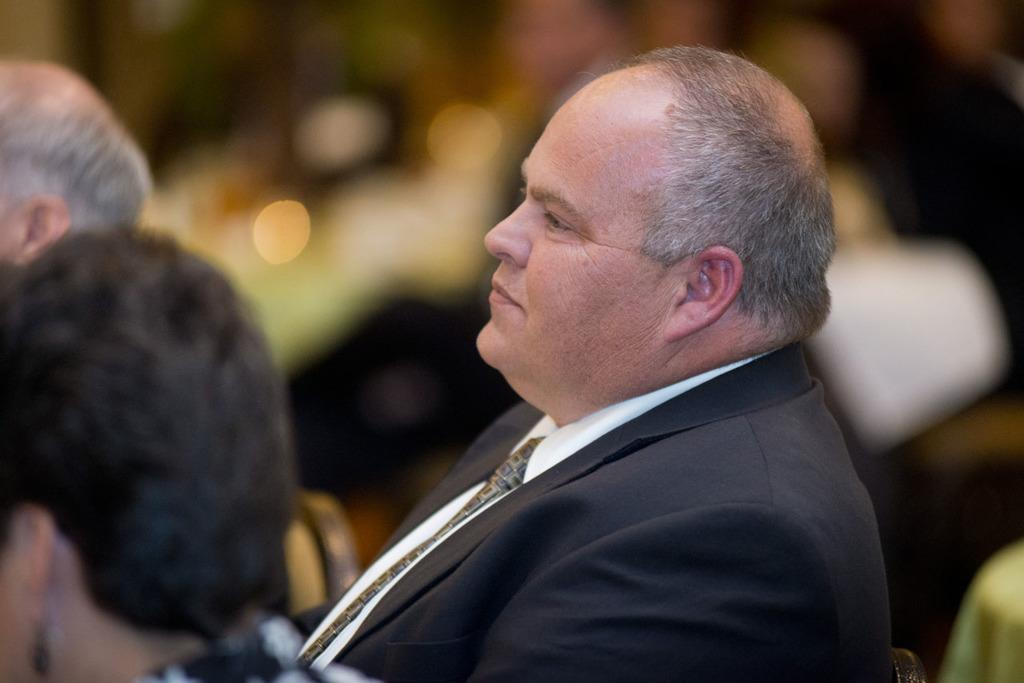Who or what is present in the image? There are people in the image. Can you describe the background of the image? The background of the image is blurry. What type of stocking is on the toe of the person in the image? There is no mention of stockings or toes in the image, so it cannot be determined if any such items are present. 